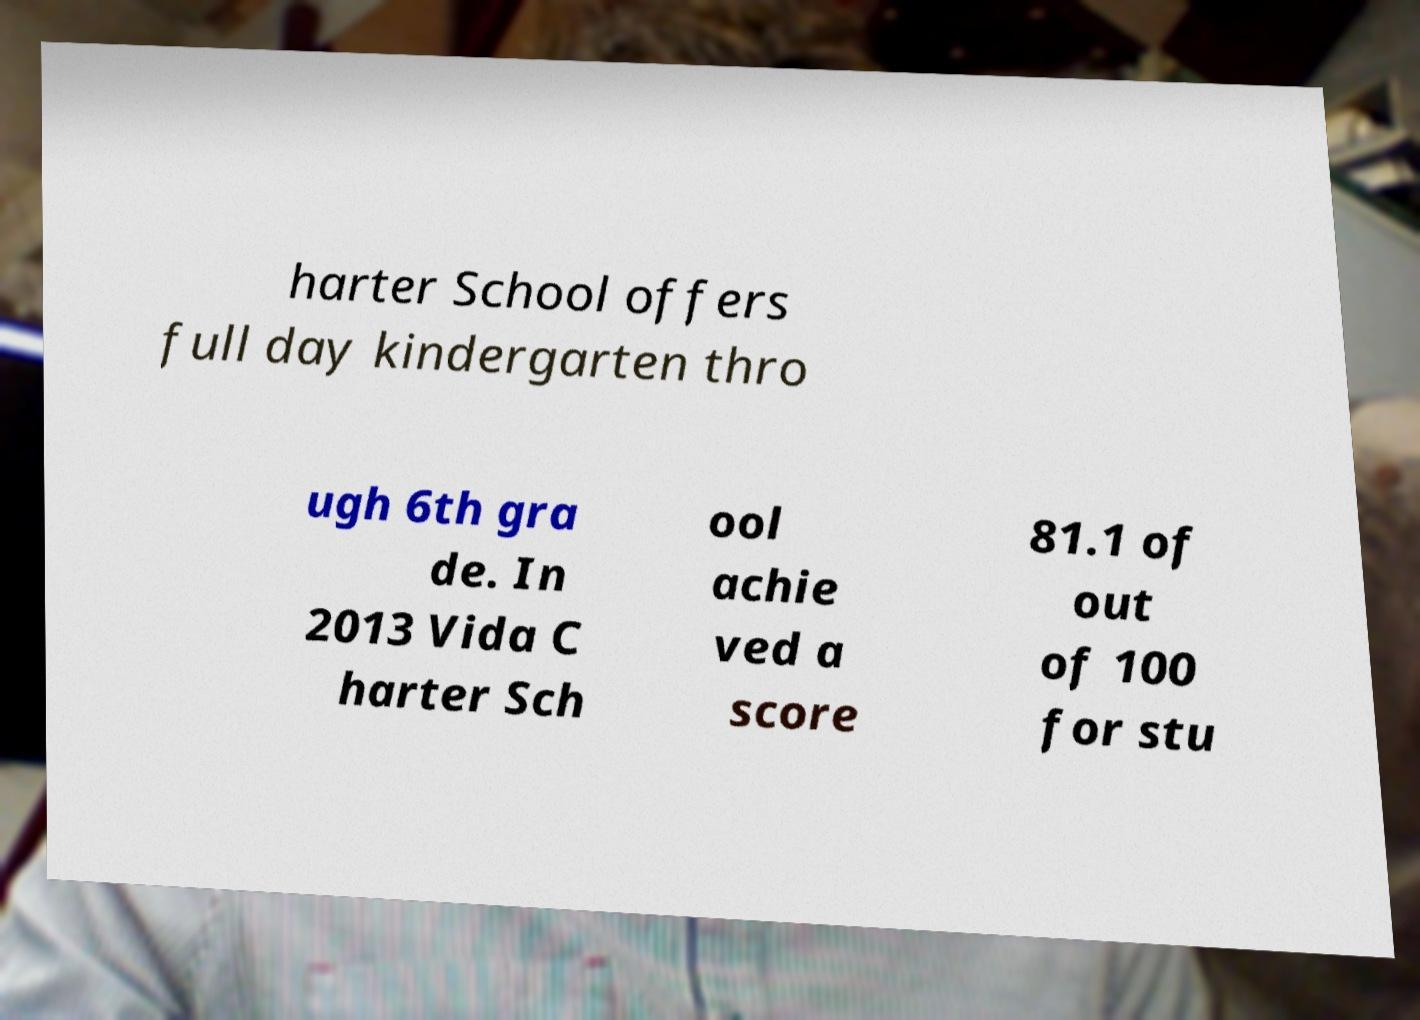There's text embedded in this image that I need extracted. Can you transcribe it verbatim? harter School offers full day kindergarten thro ugh 6th gra de. In 2013 Vida C harter Sch ool achie ved a score 81.1 of out of 100 for stu 